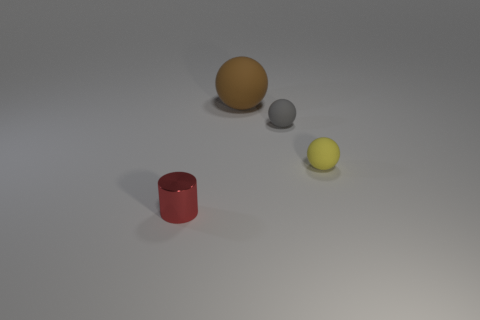Subtract all purple balls. Subtract all red cylinders. How many balls are left? 3 Add 1 tiny red objects. How many objects exist? 5 Subtract all spheres. How many objects are left? 1 Subtract 0 gray cylinders. How many objects are left? 4 Subtract all gray matte objects. Subtract all yellow cubes. How many objects are left? 3 Add 3 large brown things. How many large brown things are left? 4 Add 1 large green matte cylinders. How many large green matte cylinders exist? 1 